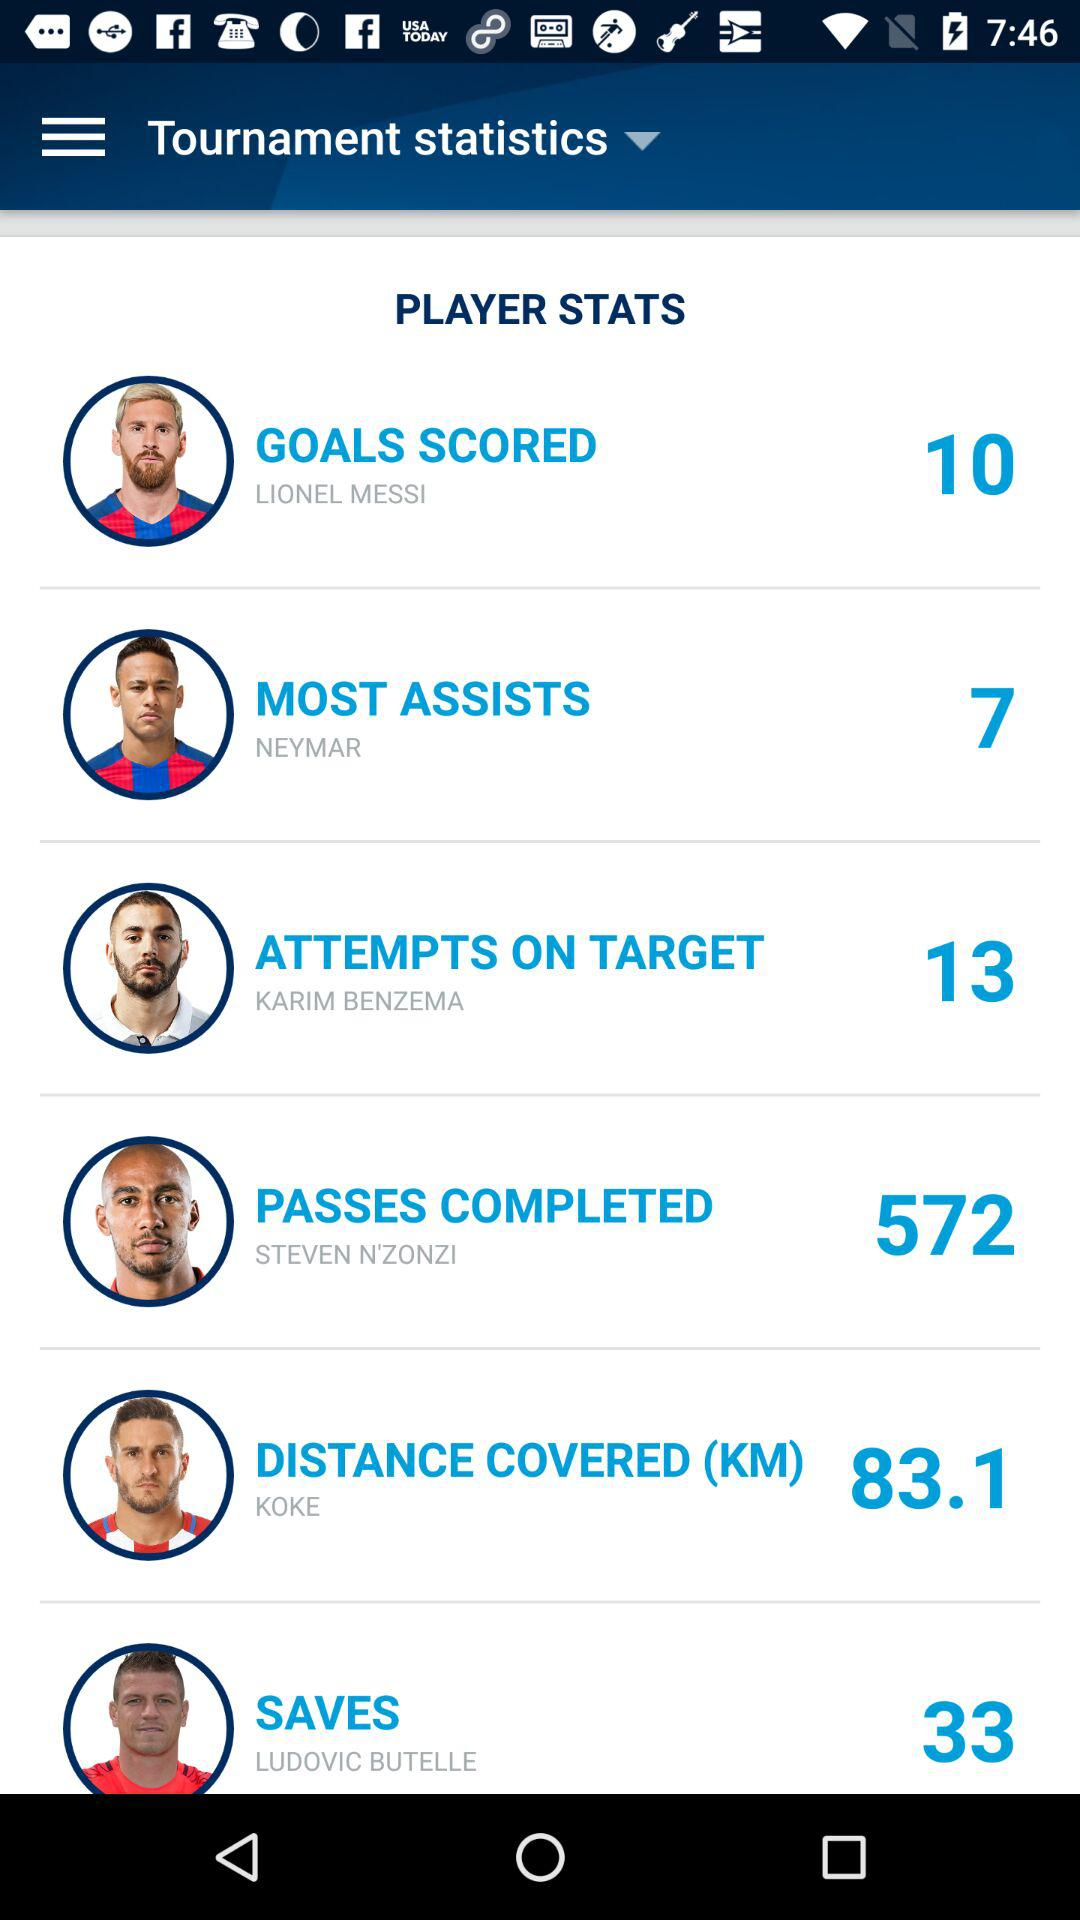How many more goals did Lionel Messi score than Neymar?
Answer the question using a single word or phrase. 3 